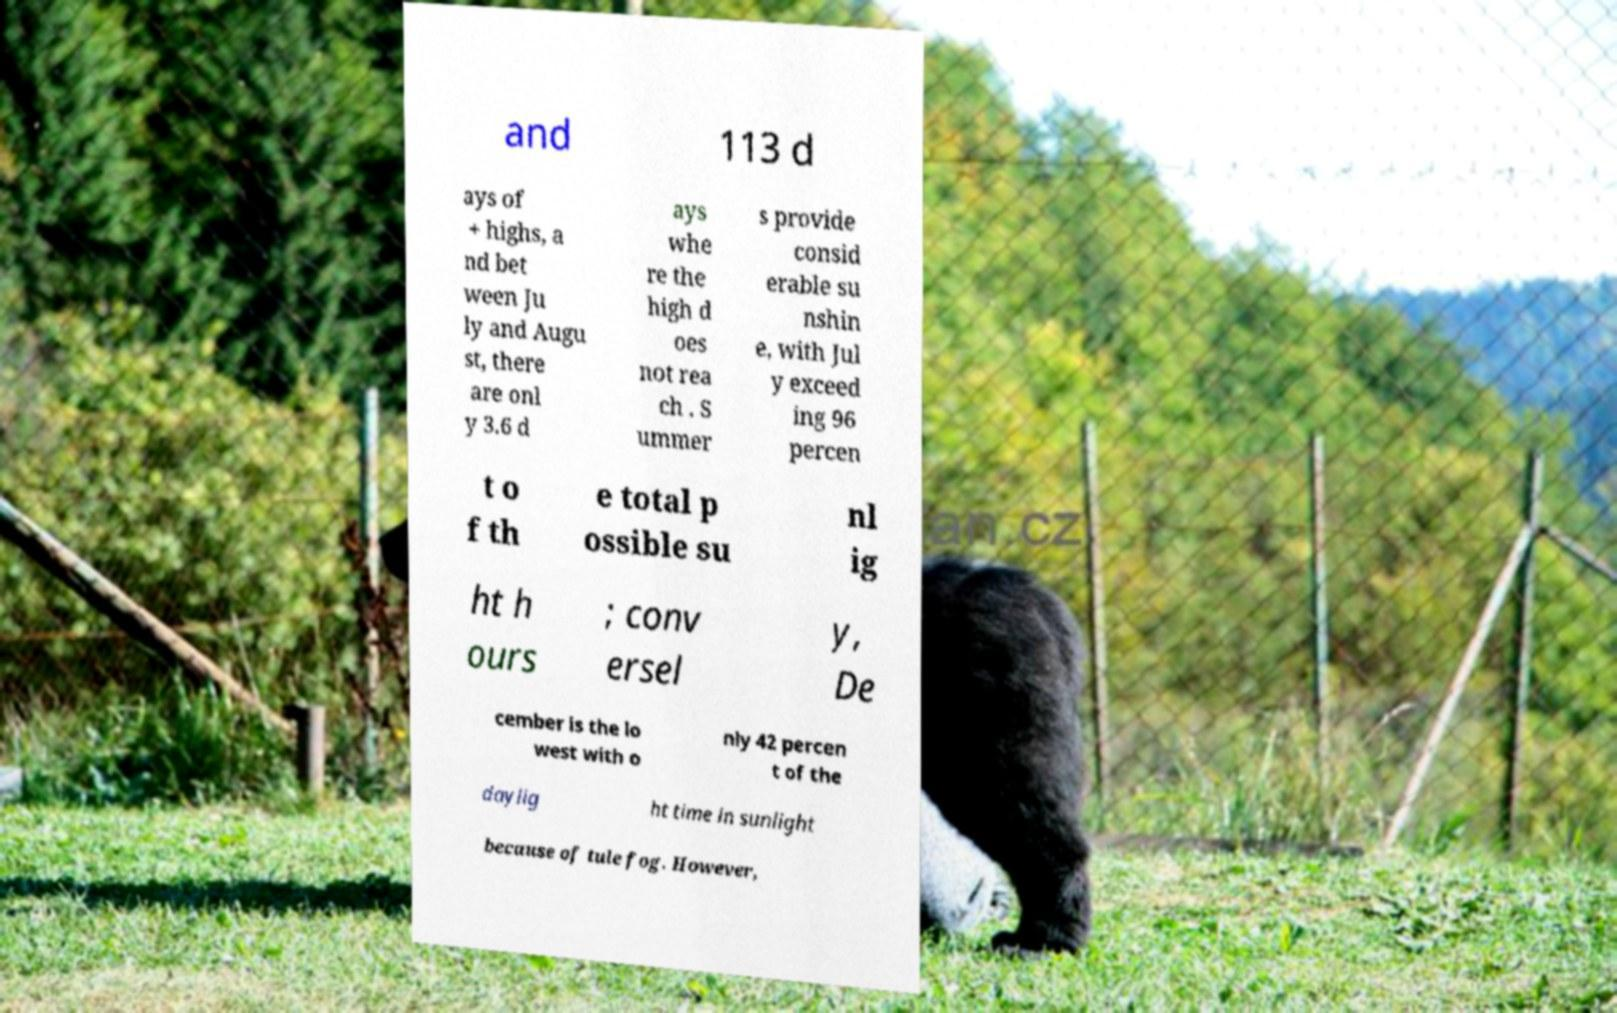What messages or text are displayed in this image? I need them in a readable, typed format. and 113 d ays of + highs, a nd bet ween Ju ly and Augu st, there are onl y 3.6 d ays whe re the high d oes not rea ch . S ummer s provide consid erable su nshin e, with Jul y exceed ing 96 percen t o f th e total p ossible su nl ig ht h ours ; conv ersel y, De cember is the lo west with o nly 42 percen t of the daylig ht time in sunlight because of tule fog. However, 